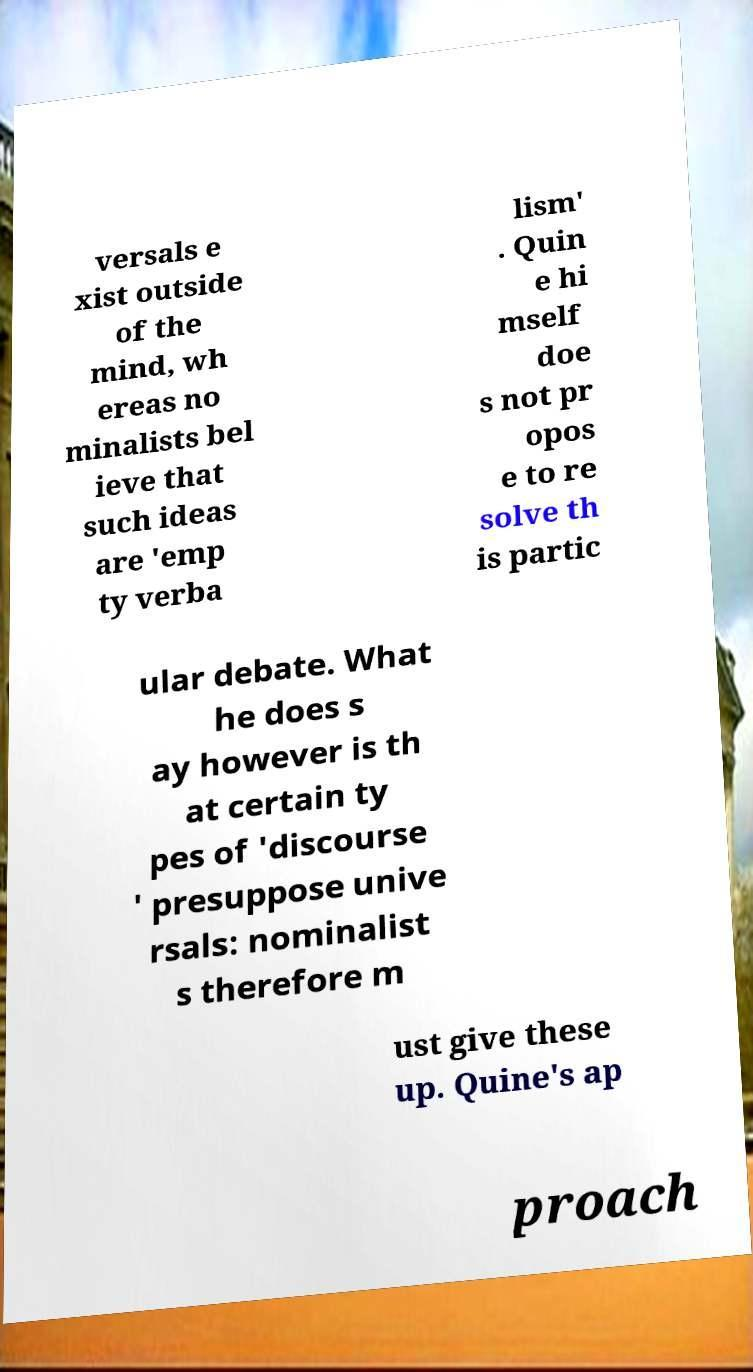Please read and relay the text visible in this image. What does it say? versals e xist outside of the mind, wh ereas no minalists bel ieve that such ideas are 'emp ty verba lism' . Quin e hi mself doe s not pr opos e to re solve th is partic ular debate. What he does s ay however is th at certain ty pes of 'discourse ' presuppose unive rsals: nominalist s therefore m ust give these up. Quine's ap proach 